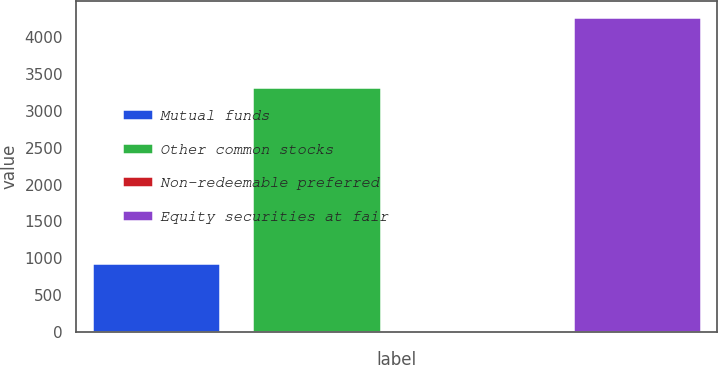<chart> <loc_0><loc_0><loc_500><loc_500><bar_chart><fcel>Mutual funds<fcel>Other common stocks<fcel>Non-redeemable preferred<fcel>Equity securities at fair<nl><fcel>935<fcel>3330<fcel>11<fcel>4276<nl></chart> 